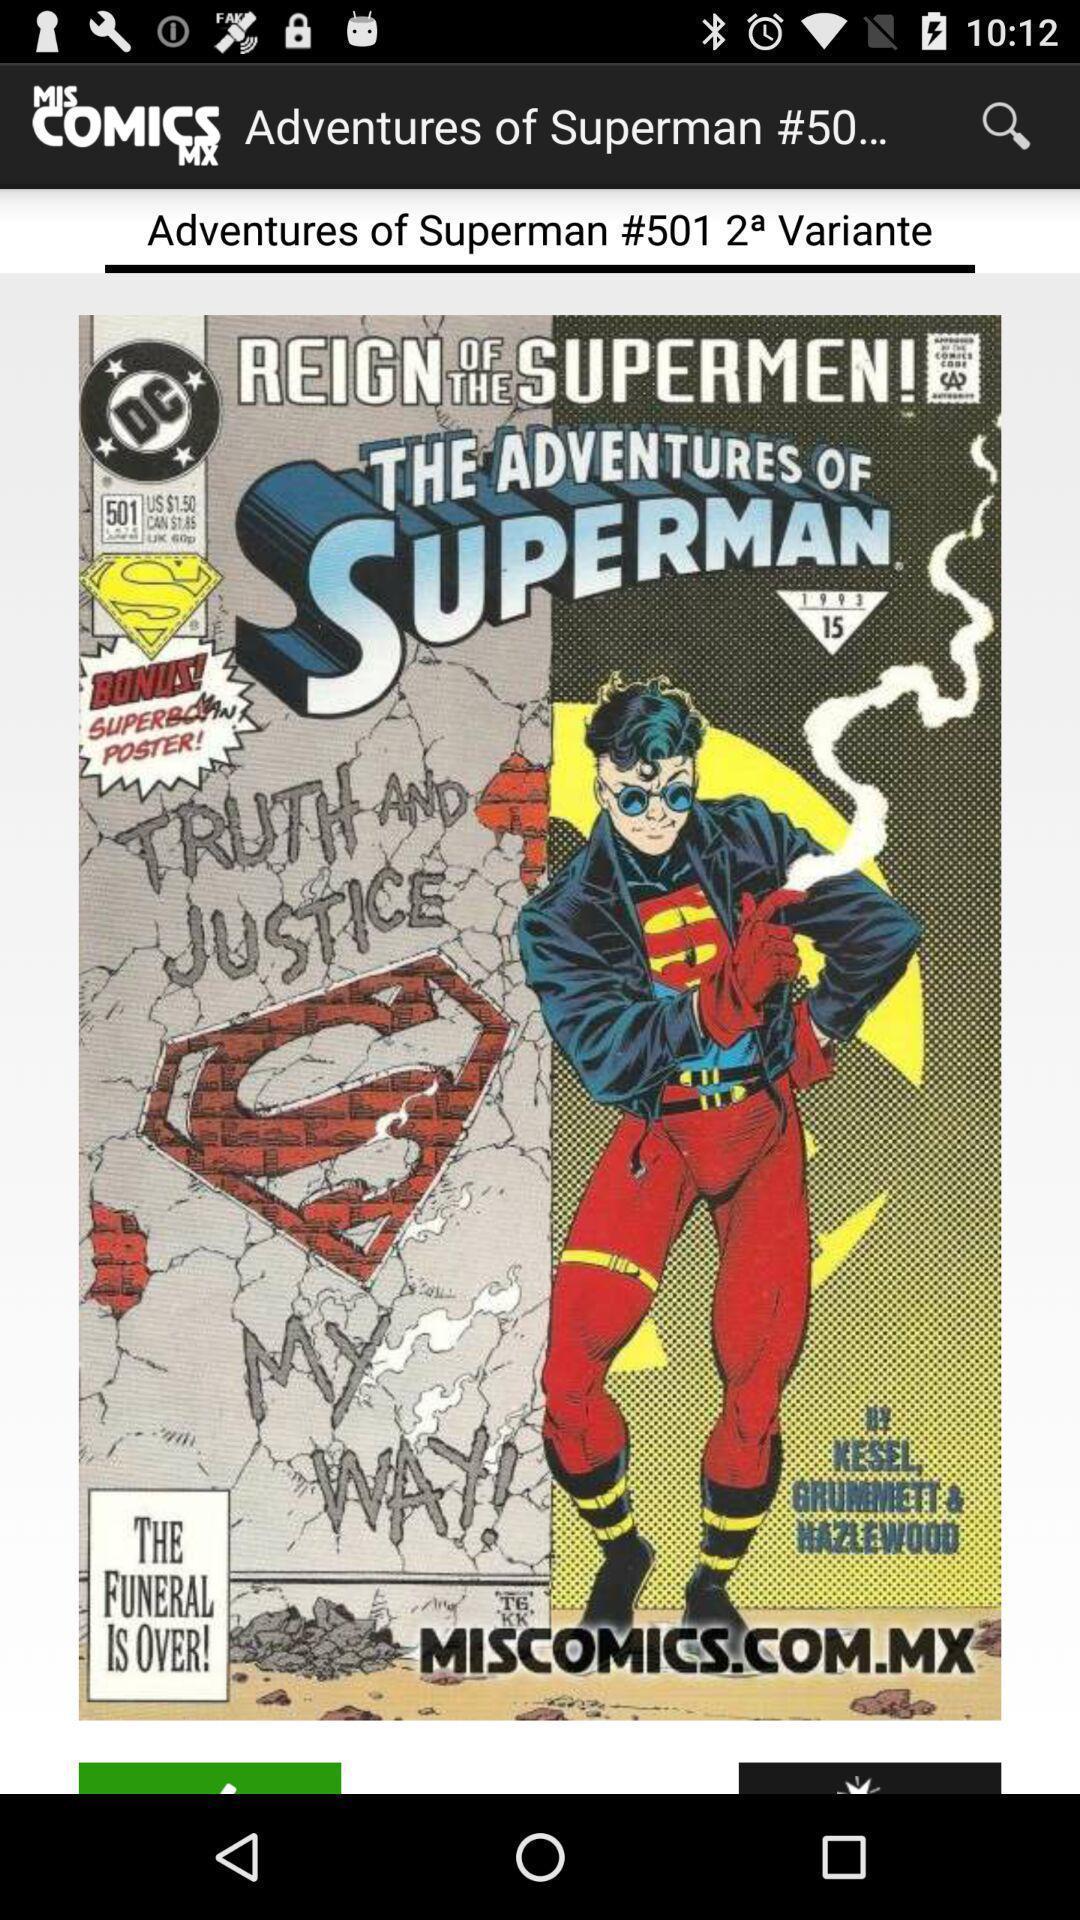What can you discern from this picture? Reign of the supermen of app. 